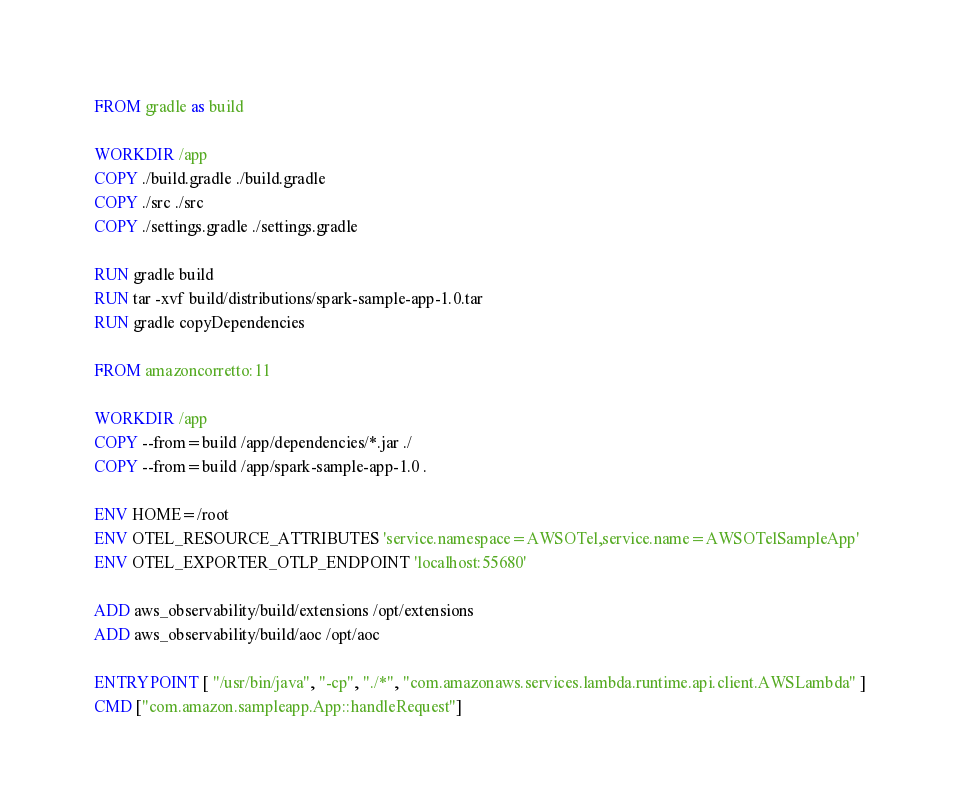Convert code to text. <code><loc_0><loc_0><loc_500><loc_500><_Dockerfile_>FROM gradle as build

WORKDIR /app
COPY ./build.gradle ./build.gradle
COPY ./src ./src
COPY ./settings.gradle ./settings.gradle

RUN gradle build
RUN tar -xvf build/distributions/spark-sample-app-1.0.tar
RUN gradle copyDependencies

FROM amazoncorretto:11 

WORKDIR /app
COPY --from=build /app/dependencies/*.jar ./
COPY --from=build /app/spark-sample-app-1.0 .

ENV HOME=/root
ENV OTEL_RESOURCE_ATTRIBUTES 'service.namespace=AWSOTel,service.name=AWSOTelSampleApp'
ENV OTEL_EXPORTER_OTLP_ENDPOINT 'localhost:55680'

ADD aws_observability/build/extensions /opt/extensions
ADD aws_observability/build/aoc /opt/aoc

ENTRYPOINT [ "/usr/bin/java", "-cp", "./*", "com.amazonaws.services.lambda.runtime.api.client.AWSLambda" ]
CMD ["com.amazon.sampleapp.App::handleRequest"]
</code> 